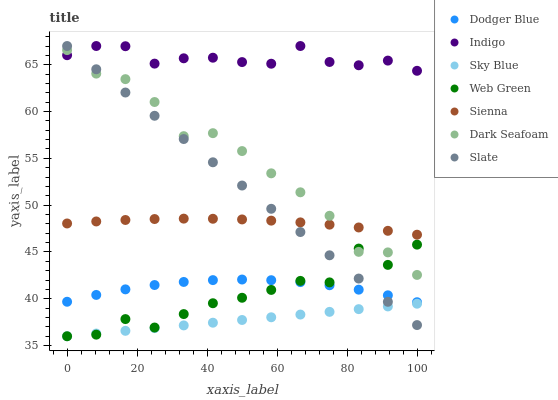Does Sky Blue have the minimum area under the curve?
Answer yes or no. Yes. Does Indigo have the maximum area under the curve?
Answer yes or no. Yes. Does Slate have the minimum area under the curve?
Answer yes or no. No. Does Slate have the maximum area under the curve?
Answer yes or no. No. Is Slate the smoothest?
Answer yes or no. Yes. Is Web Green the roughest?
Answer yes or no. Yes. Is Web Green the smoothest?
Answer yes or no. No. Is Slate the roughest?
Answer yes or no. No. Does Web Green have the lowest value?
Answer yes or no. Yes. Does Slate have the lowest value?
Answer yes or no. No. Does Slate have the highest value?
Answer yes or no. Yes. Does Web Green have the highest value?
Answer yes or no. No. Is Sienna less than Indigo?
Answer yes or no. Yes. Is Sienna greater than Sky Blue?
Answer yes or no. Yes. Does Indigo intersect Dark Seafoam?
Answer yes or no. Yes. Is Indigo less than Dark Seafoam?
Answer yes or no. No. Is Indigo greater than Dark Seafoam?
Answer yes or no. No. Does Sienna intersect Indigo?
Answer yes or no. No. 